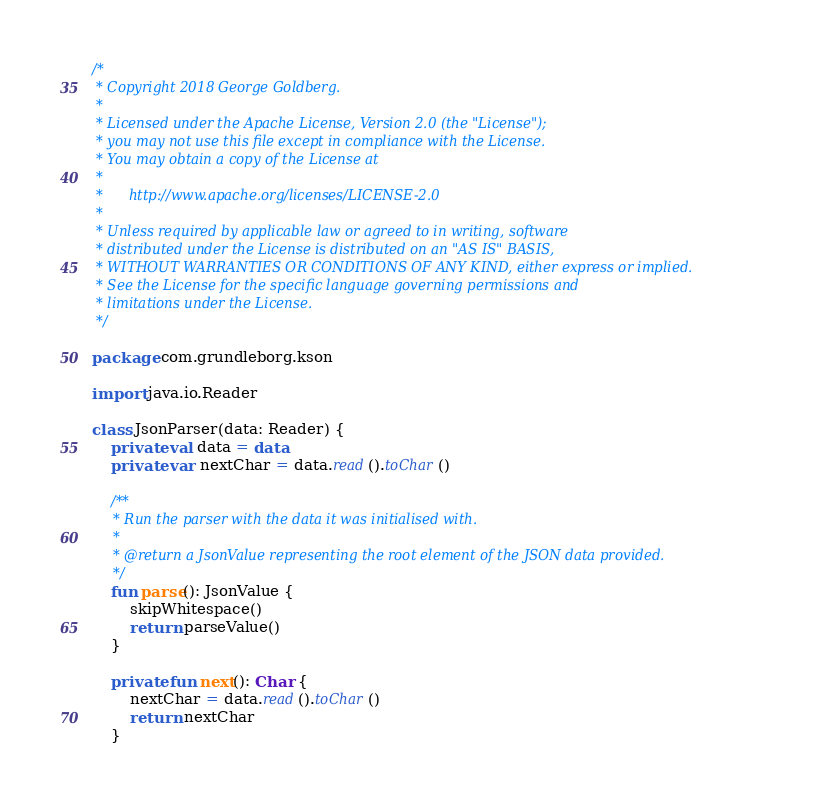Convert code to text. <code><loc_0><loc_0><loc_500><loc_500><_Kotlin_>/*
 * Copyright 2018 George Goldberg.
 *
 * Licensed under the Apache License, Version 2.0 (the "License");
 * you may not use this file except in compliance with the License.
 * You may obtain a copy of the License at
 *
 *      http://www.apache.org/licenses/LICENSE-2.0
 *
 * Unless required by applicable law or agreed to in writing, software
 * distributed under the License is distributed on an "AS IS" BASIS,
 * WITHOUT WARRANTIES OR CONDITIONS OF ANY KIND, either express or implied.
 * See the License for the specific language governing permissions and
 * limitations under the License.
 */

package com.grundleborg.kson

import java.io.Reader

class JsonParser(data: Reader) {
    private val data = data
    private var nextChar = data.read().toChar()

    /**
     * Run the parser with the data it was initialised with.
     *
     * @return a JsonValue representing the root element of the JSON data provided.
     */
    fun parse(): JsonValue {
        skipWhitespace()
        return parseValue()
    }

    private fun next(): Char {
        nextChar = data.read().toChar()
        return nextChar
    }
</code> 